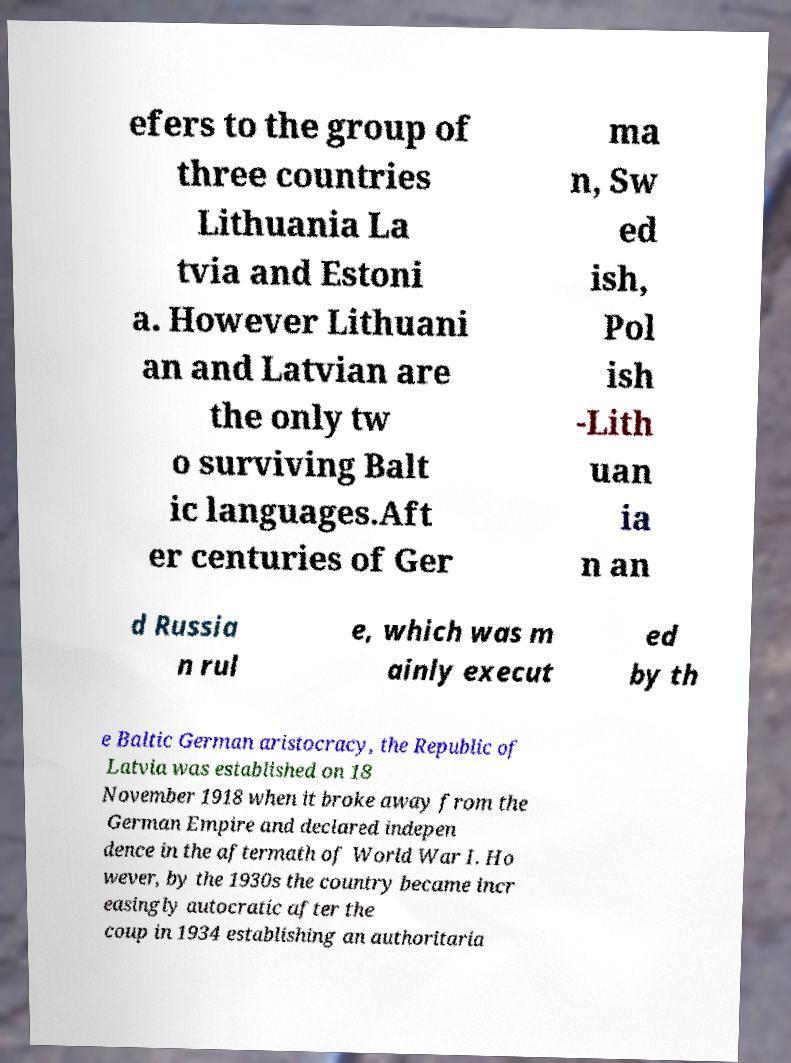Could you extract and type out the text from this image? efers to the group of three countries Lithuania La tvia and Estoni a. However Lithuani an and Latvian are the only tw o surviving Balt ic languages.Aft er centuries of Ger ma n, Sw ed ish, Pol ish -Lith uan ia n an d Russia n rul e, which was m ainly execut ed by th e Baltic German aristocracy, the Republic of Latvia was established on 18 November 1918 when it broke away from the German Empire and declared indepen dence in the aftermath of World War I. Ho wever, by the 1930s the country became incr easingly autocratic after the coup in 1934 establishing an authoritaria 